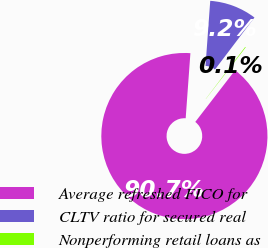Convert chart. <chart><loc_0><loc_0><loc_500><loc_500><pie_chart><fcel>Average refreshed FICO for<fcel>CLTV ratio for secured real<fcel>Nonperforming retail loans as<nl><fcel>90.7%<fcel>9.18%<fcel>0.12%<nl></chart> 